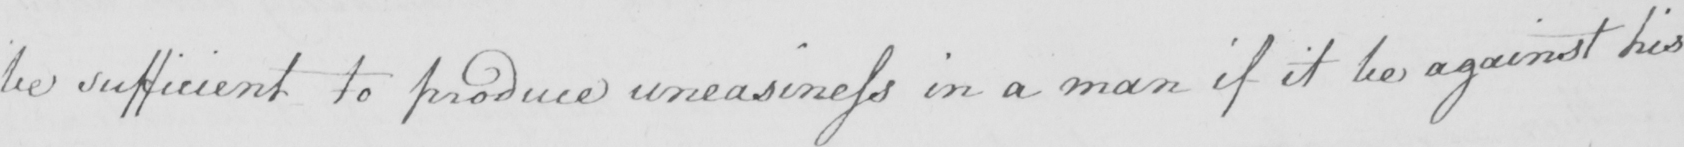What does this handwritten line say? be sufficient to produce uneasiness in a man if it be against his 